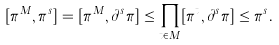Convert formula to latex. <formula><loc_0><loc_0><loc_500><loc_500>[ \pi ^ { M } , \pi ^ { s } ] & = [ \pi ^ { M } , \partial ^ { s } \pi ] \leq \prod _ { t \in M } [ \pi ^ { t } , \partial ^ { s } \pi ] \leq \pi ^ { s } .</formula> 